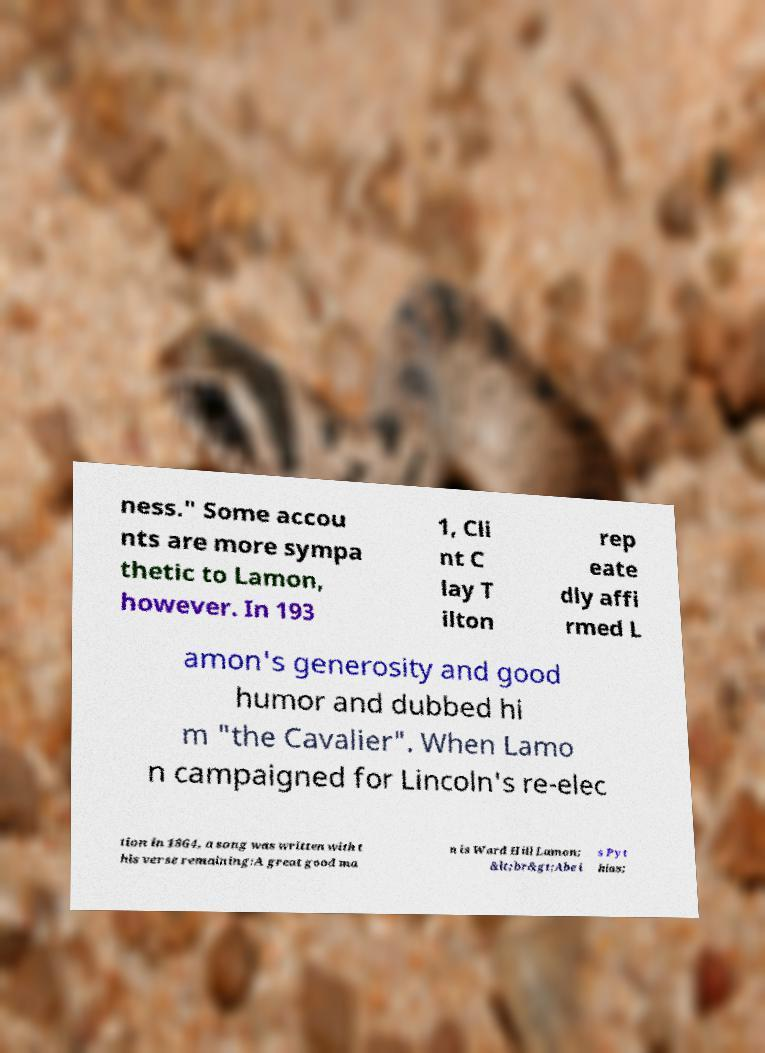I need the written content from this picture converted into text. Can you do that? ness." Some accou nts are more sympa thetic to Lamon, however. In 193 1, Cli nt C lay T ilton rep eate dly affi rmed L amon's generosity and good humor and dubbed hi m "the Cavalier". When Lamo n campaigned for Lincoln's re-elec tion in 1864, a song was written with t his verse remaining:A great good ma n is Ward Hill Lamon; &lt;br&gt;Abe i s Pyt hias; 